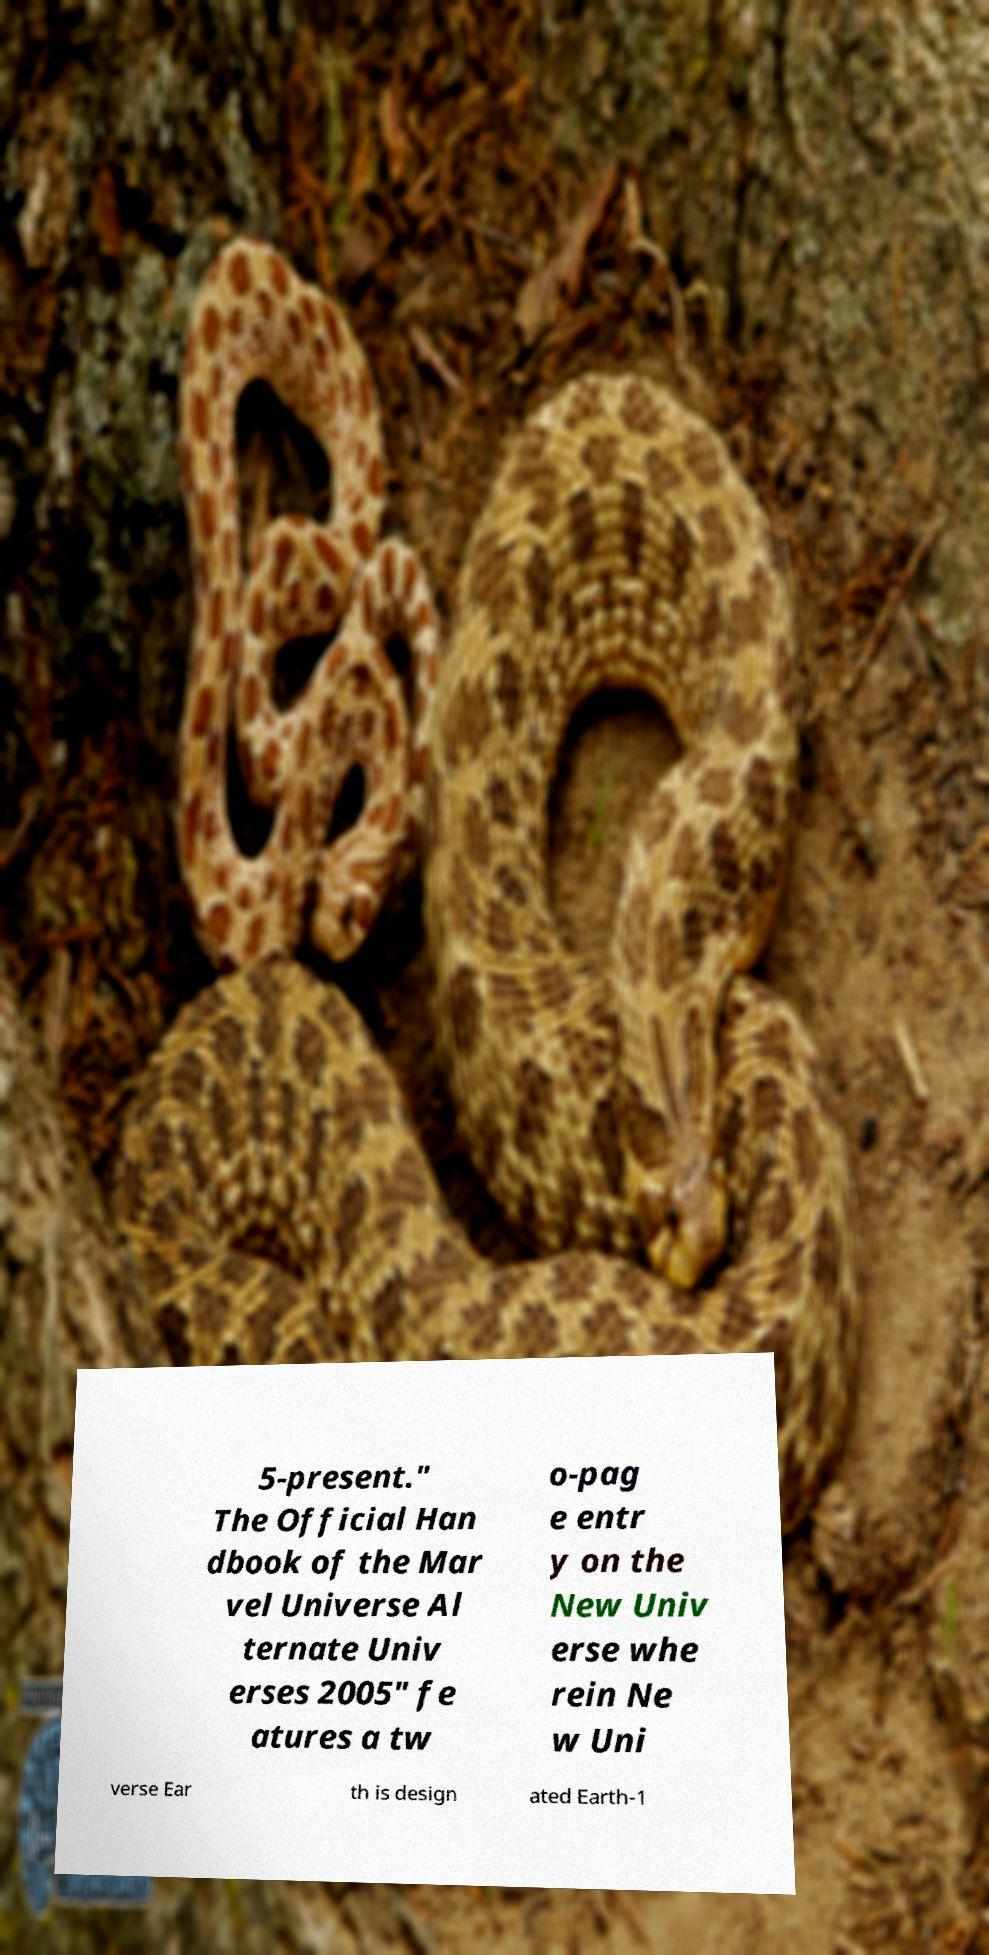Please identify and transcribe the text found in this image. 5-present." The Official Han dbook of the Mar vel Universe Al ternate Univ erses 2005" fe atures a tw o-pag e entr y on the New Univ erse whe rein Ne w Uni verse Ear th is design ated Earth-1 